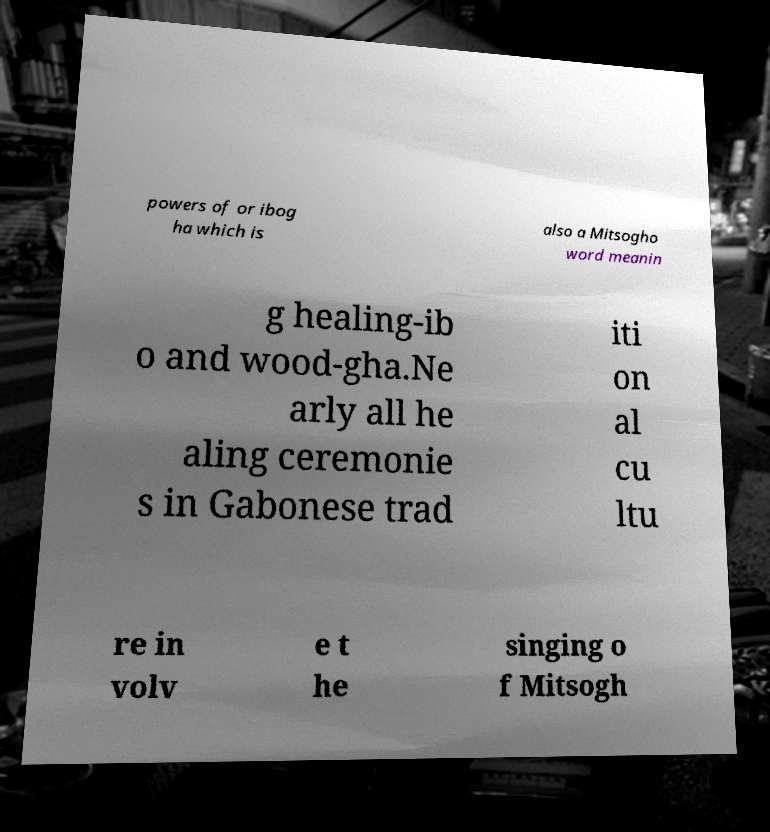Can you accurately transcribe the text from the provided image for me? powers of or ibog ha which is also a Mitsogho word meanin g healing-ib o and wood-gha.Ne arly all he aling ceremonie s in Gabonese trad iti on al cu ltu re in volv e t he singing o f Mitsogh 